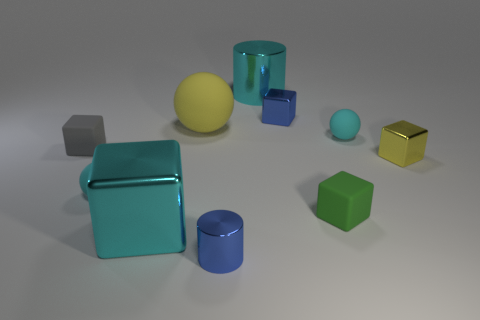What material is the tiny object that is the same color as the tiny metal cylinder?
Provide a succinct answer. Metal. There is a cyan cylinder that is the same size as the yellow matte object; what material is it?
Your answer should be very brief. Metal. Is there a cyan sphere that has the same size as the green rubber block?
Provide a succinct answer. Yes. Does the small green rubber thing have the same shape as the tiny yellow thing?
Your response must be concise. Yes. There is a small cyan thing in front of the cyan matte object on the right side of the large cube; is there a object that is in front of it?
Provide a short and direct response. Yes. How many other objects are the same color as the small cylinder?
Provide a short and direct response. 1. There is a blue metal object in front of the yellow shiny cube; does it have the same size as the cyan cylinder behind the cyan metal cube?
Give a very brief answer. No. Is the number of blue cubes that are behind the cyan cylinder the same as the number of large cyan objects behind the yellow rubber thing?
Give a very brief answer. No. There is a blue metal cylinder; does it have the same size as the metallic cube that is to the left of the large cyan cylinder?
Your response must be concise. No. What material is the tiny blue object that is in front of the large object that is in front of the tiny gray rubber cube?
Make the answer very short. Metal. 